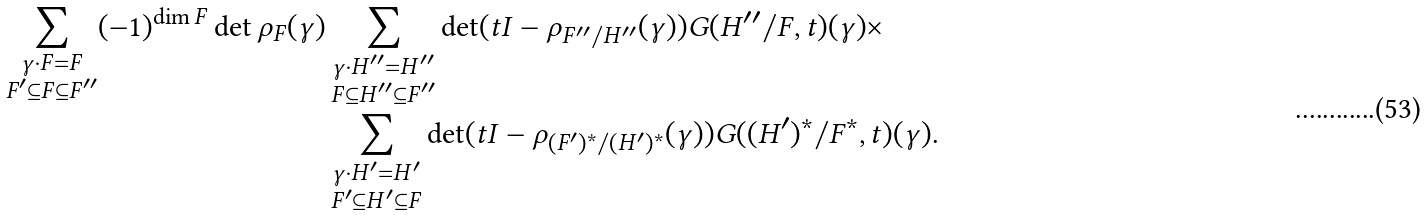<formula> <loc_0><loc_0><loc_500><loc_500>\sum _ { \substack { \gamma \cdot F = F \\ F ^ { \prime } \subseteq F \subseteq F ^ { \prime \prime } } } ( - 1 ) ^ { \dim F } \det \rho _ { F } ( \gamma ) & \sum _ { \substack { \gamma \cdot H ^ { \prime \prime } = H ^ { \prime \prime } \\ F \subseteq H ^ { \prime \prime } \subseteq F ^ { \prime \prime } } } \det ( t I - \rho _ { F ^ { \prime \prime } / H ^ { \prime \prime } } ( \gamma ) ) G ( H ^ { \prime \prime } / F , t ) ( \gamma ) \times \\ & \sum _ { \substack { \gamma \cdot H ^ { \prime } = H ^ { \prime } \\ F ^ { \prime } \subseteq H ^ { \prime } \subseteq F } } \det ( t I - \rho _ { ( F ^ { \prime } ) ^ { * } / ( H ^ { \prime } ) ^ { * } } ( \gamma ) ) G ( ( H ^ { \prime } ) ^ { * } / F ^ { * } , t ) ( \gamma ) .</formula> 